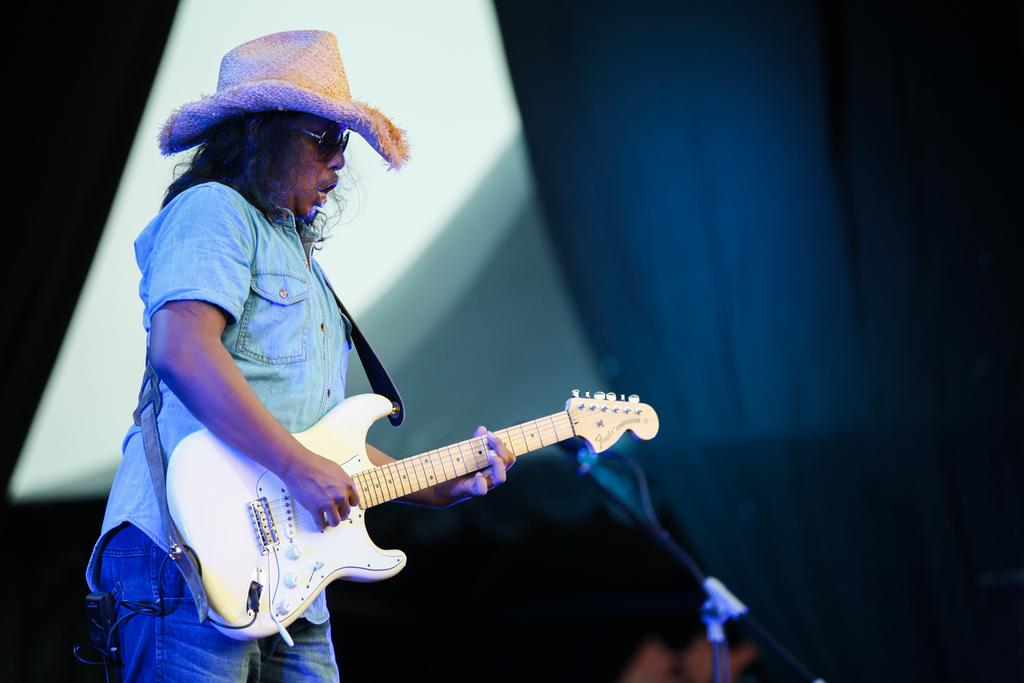What is the man in the image doing? The man is playing a guitar in the image. What accessories is the man wearing while playing the guitar? The man is wearing goggles and a hat. What type of geese can be seen flying over the man's head in the image? There are no geese present in the image; the man is playing a guitar while wearing goggles and a hat. 